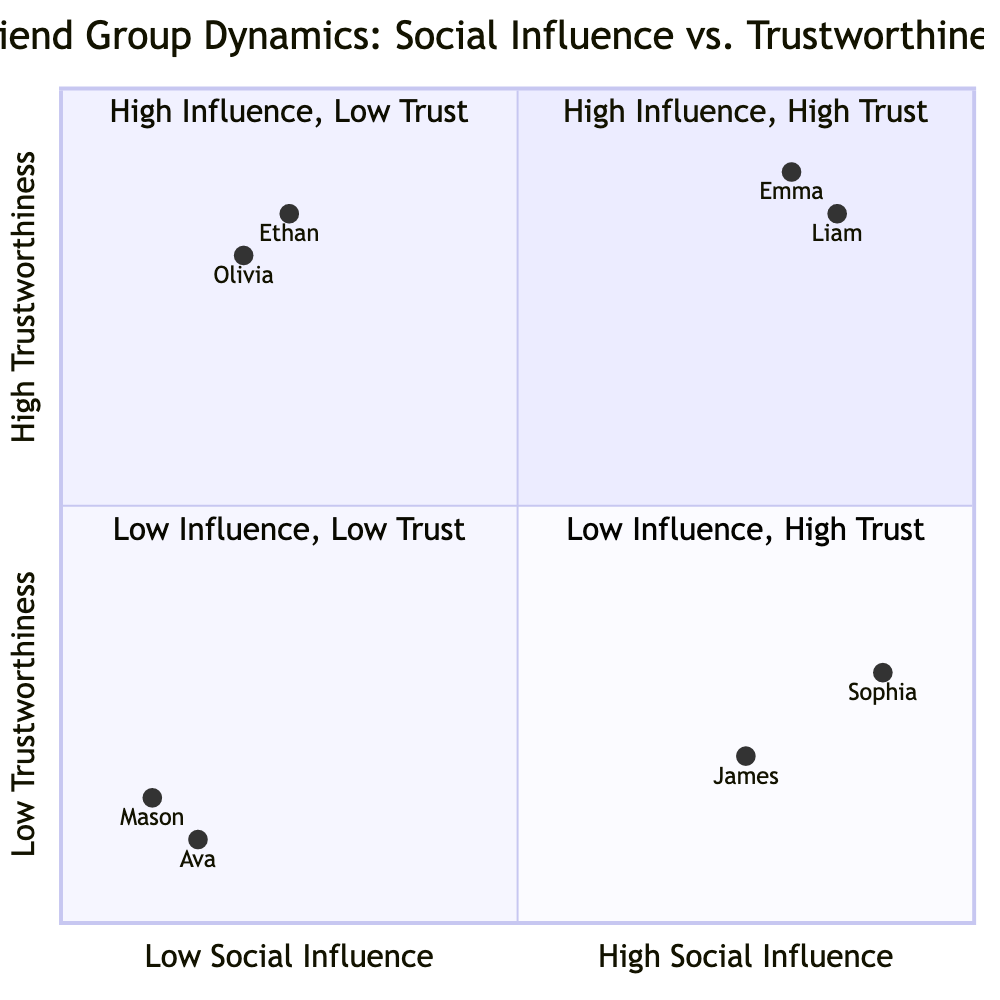What are the examples of friends in the High Influence, High Trust quadrant? The High Influence, High Trust quadrant contains Emma (Class President) and Liam (Head Cheerleader) as examples of friends who are both highly influential and trustworthy.
Answer: Emma, Liam How many friends are in the Low Influence, Low Trust quadrant? In the Low Influence, Low Trust quadrant, there are two friends: Mason (Quiet Backbencher) and Ava (New Student). Thus, the count is two.
Answer: 2 What is Liam's level of Social Influence on the chart? Liam is positioned at 0.85 on the Social Influence scale, which indicates a high level of influence.
Answer: 0.85 What quadrant is associated with Sophia? Sophia is placed in the High Influence, Low Trust quadrant, where she has significant influence but is not considered fully trustworthy.
Answer: High Influence, Low Trust Which friend exhibits the highest Trustworthiness? Among all the friends plotted in the quadrants, Olivia has the highest Trustworthiness score of 0.8.
Answer: 0.8 If a friend is in the Low Influence, High Trust quadrant, what does that imply about their influence and trustworthiness? Friends in the Low Influence, High Trust quadrant are trustworthy but do not exert much social influence.
Answer: Trustworthy, Low Influence How would you describe the characteristics of friends in the High Influence, Low Trust quadrant? Friends in the High Influence, Low Trust quadrant have significant social influence, making them popular, but they might not be seen as reliable or trustworthy.
Answer: Influential but not trustworthy What is the Trustworthiness rating of James? James is positioned at 0.2 on the Trustworthiness scale, indicating he has low trustworthiness.
Answer: 0.2 Who has the lowest Social Influence according to the chart? Mason has the lowest Social Influence at 0.1, making him the least influential friend in the chart.
Answer: Mason 